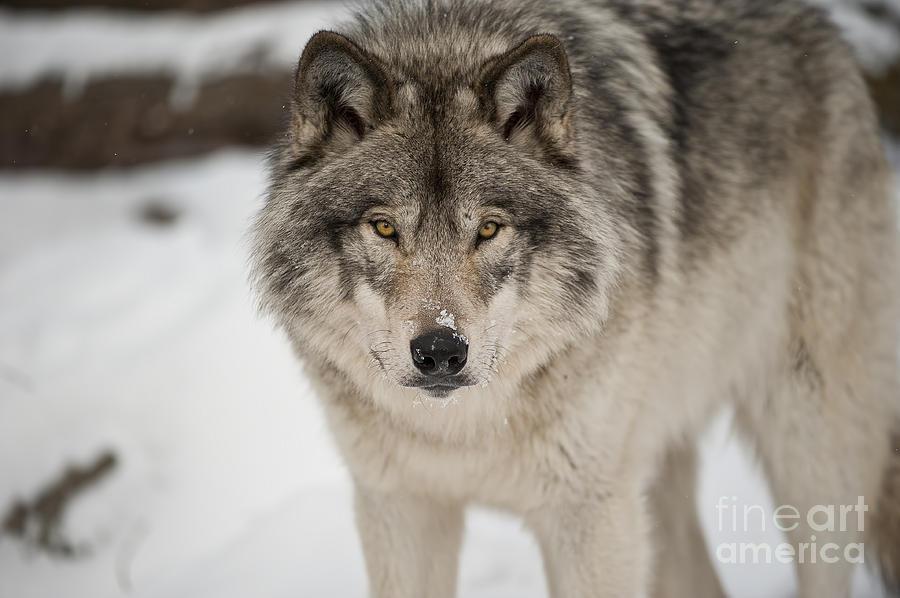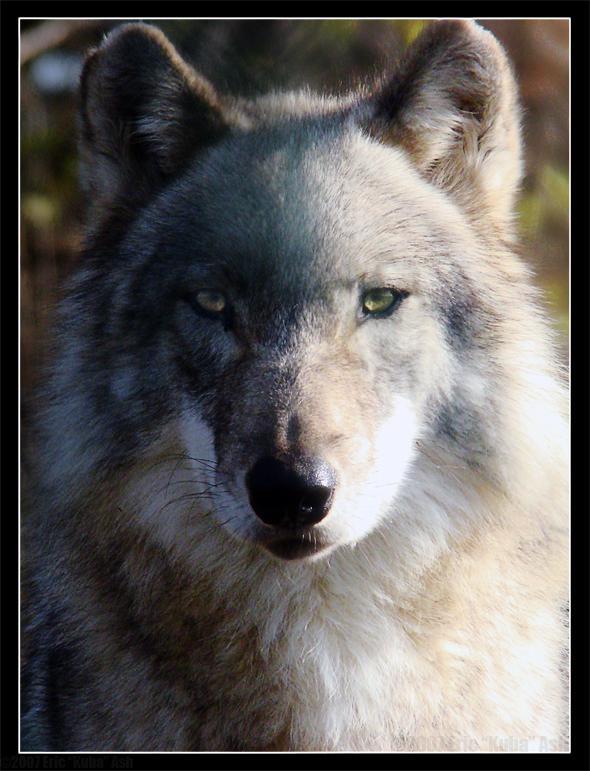The first image is the image on the left, the second image is the image on the right. Examine the images to the left and right. Is the description "The left image contains at least two wolves." accurate? Answer yes or no. No. The first image is the image on the left, the second image is the image on the right. For the images displayed, is the sentence "The right image features one wolf reclining with its body turned leftward and its gaze slightly rightward, and the left image contains at least three wolves." factually correct? Answer yes or no. No. 